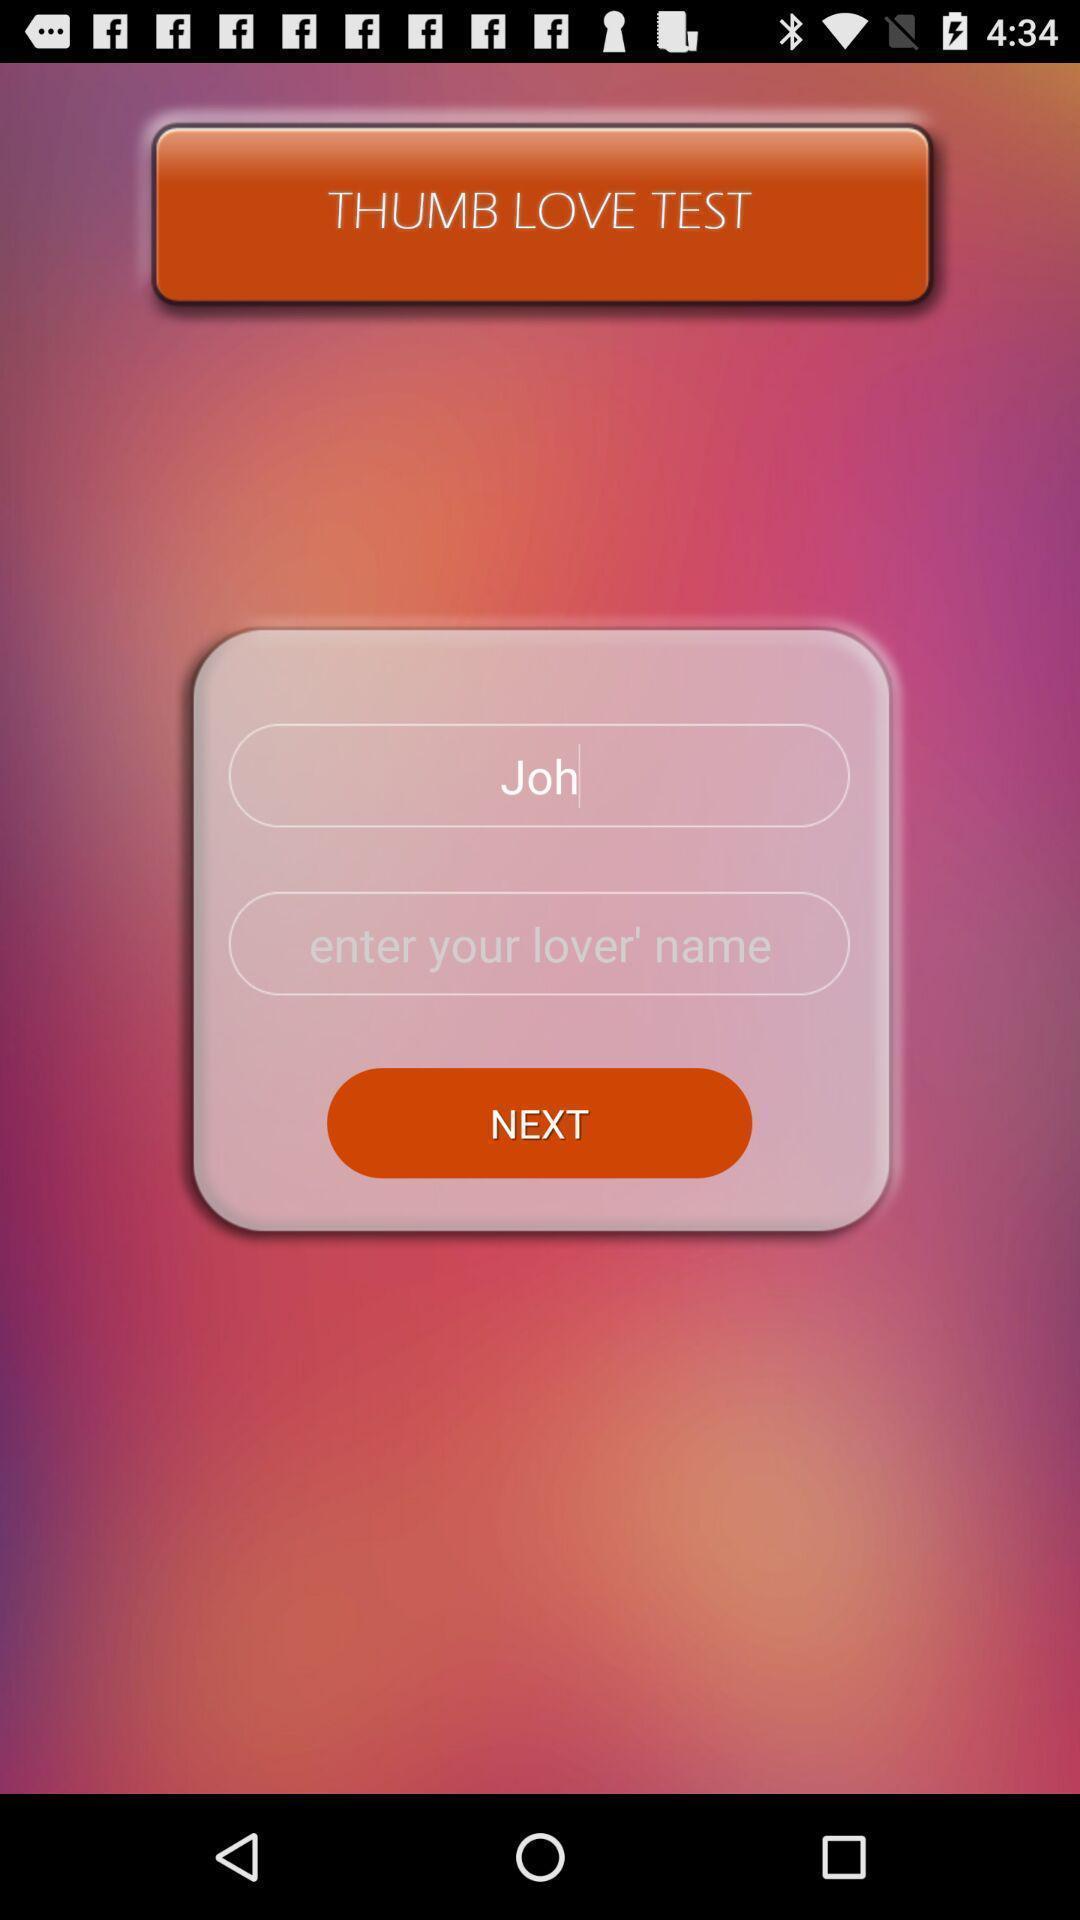What is the overall content of this screenshot? Page displaying to enter the lover name. 